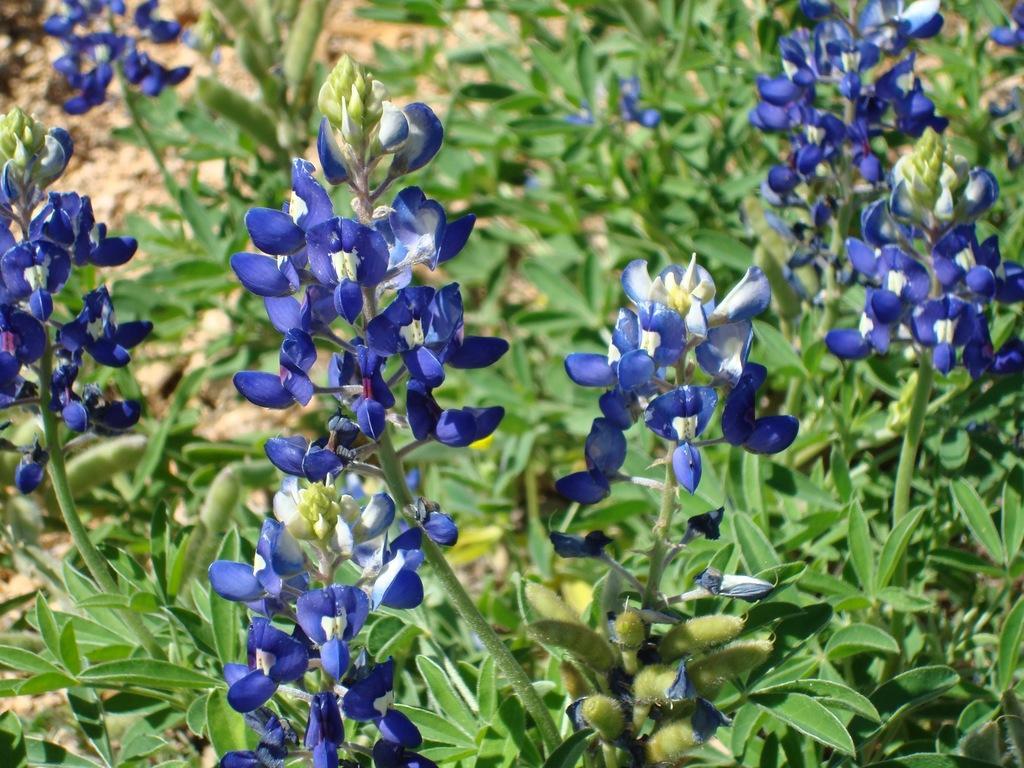How would you summarize this image in a sentence or two? In this picture I can observe blue color flowers. In the background there are some plants. 